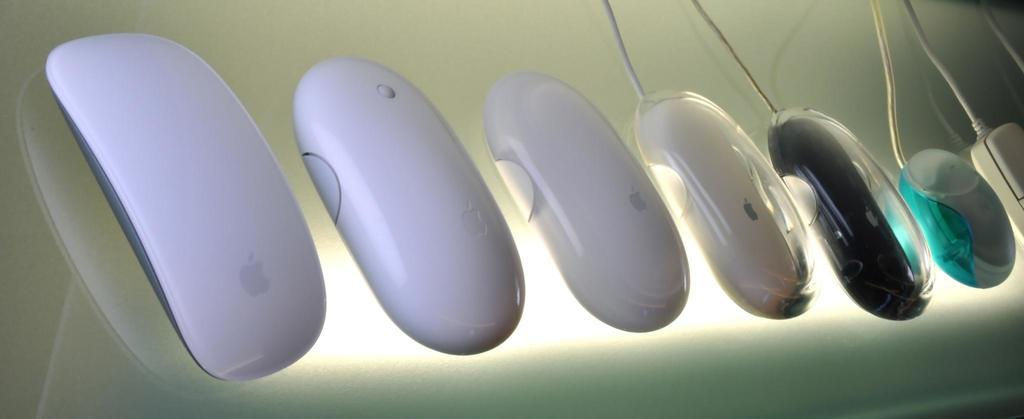What type of animals are in the image? There are mice in the image. What colors are the mice? The mice are in white, black, green, and grey colors. What surface are the mice on? The mice are on a glass surface. Can you describe the lighting in the image? There is light visible in the image. What else can be seen in the image besides the mice? There are wires in the image. What type of doll is the farmer holding in the image? There is no doll or farmer present in the image; it features mice on a glass surface with wires visible. 